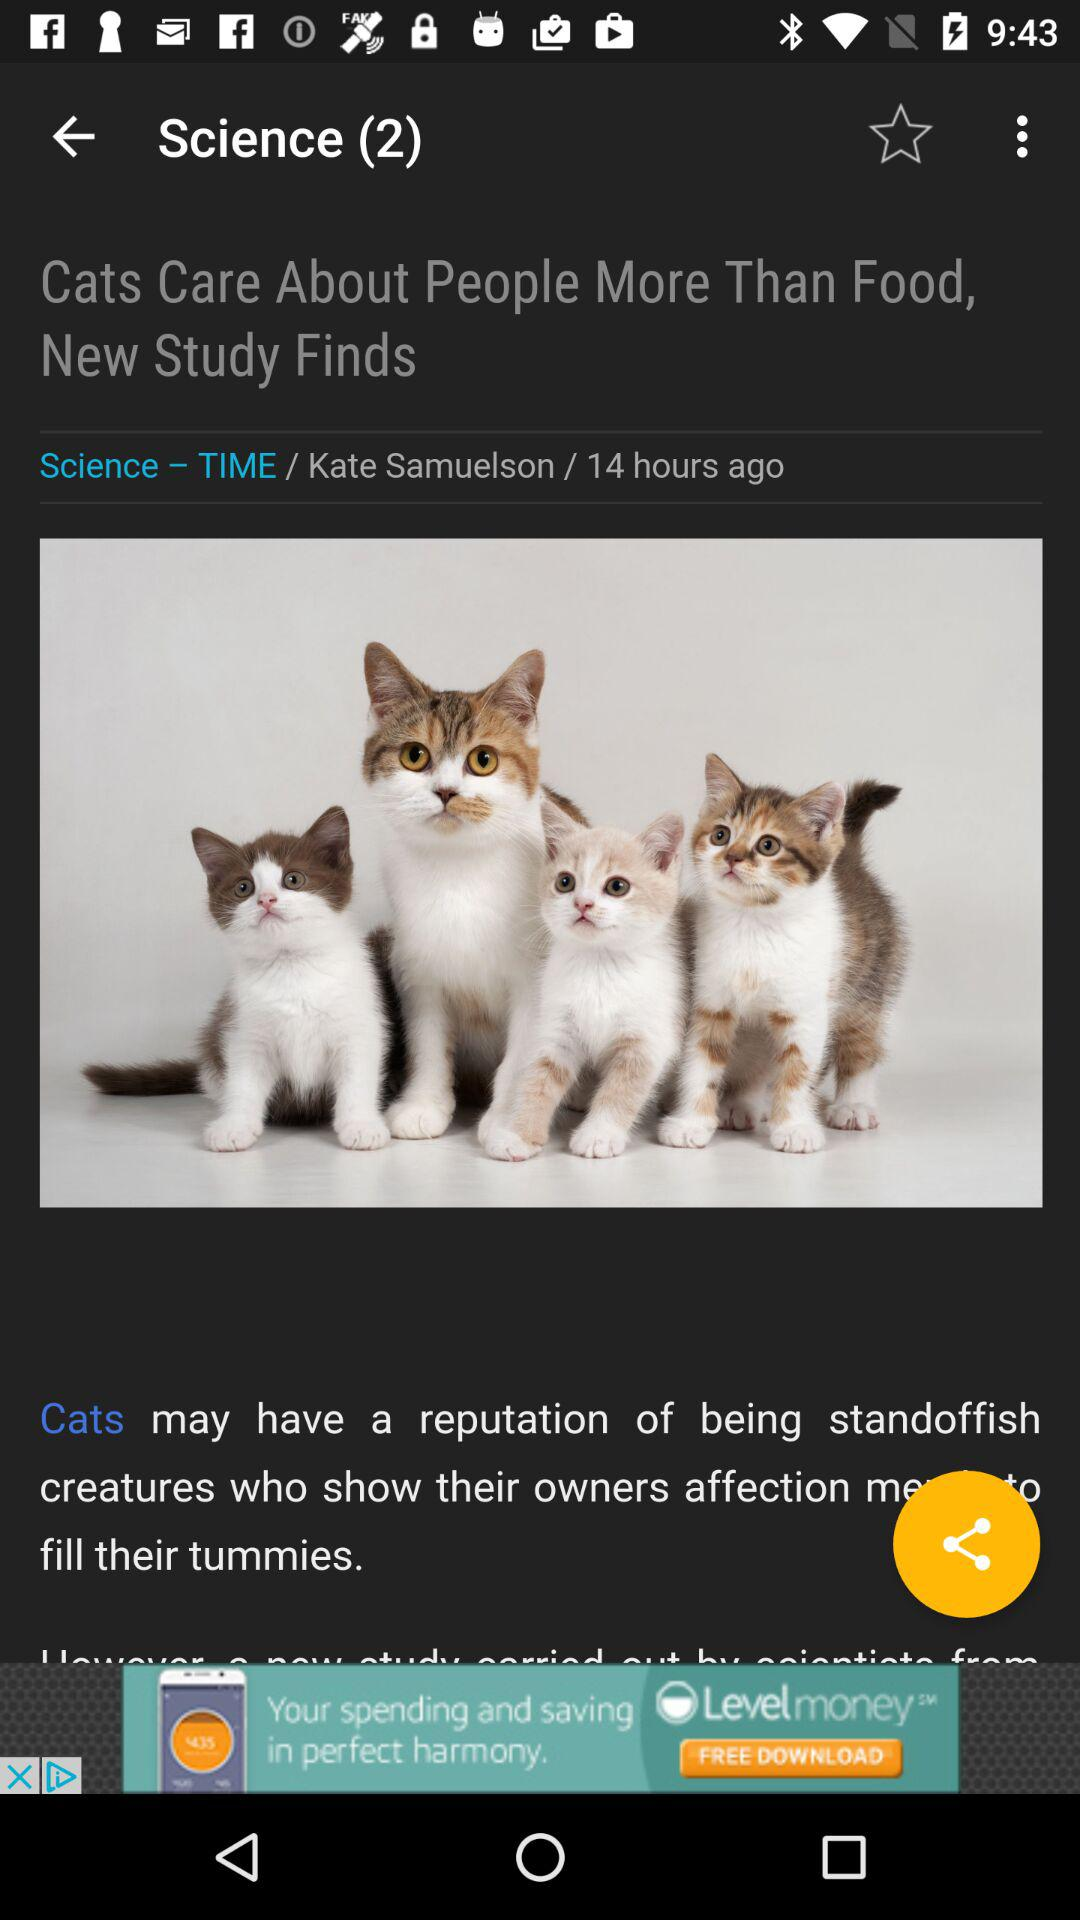What is the author's name? The author's name is Kate Samuelson. 